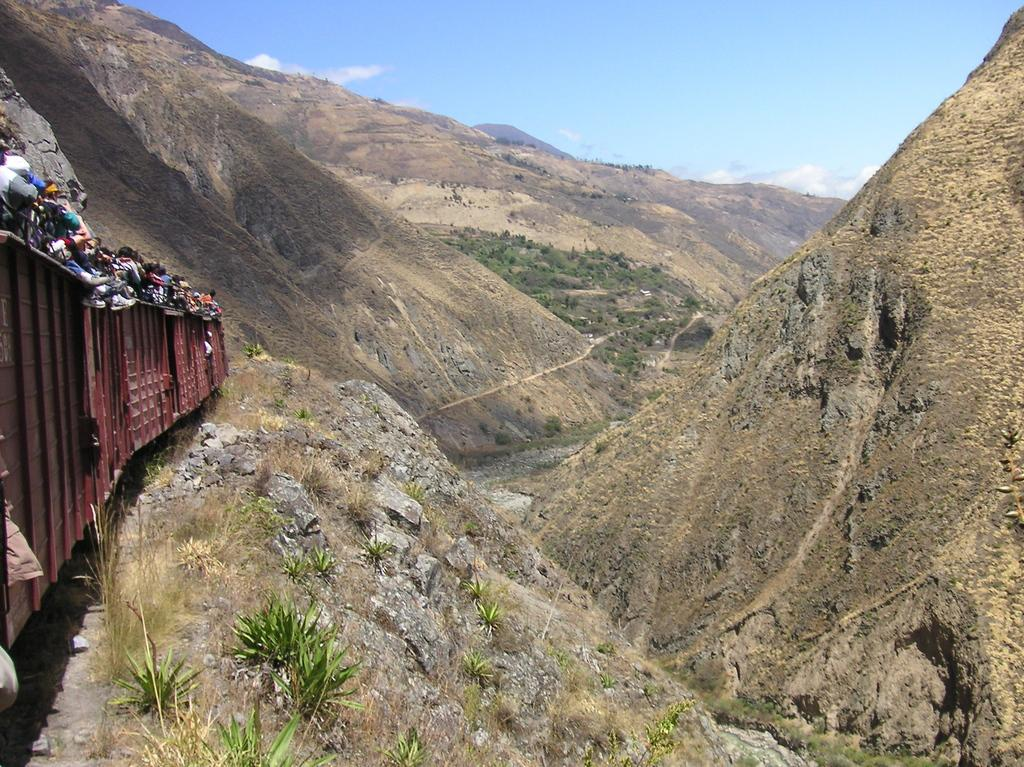What type of landscape can be seen in the image? There are hills in the image. What type of vegetation is present in the image? There is grass in the image. What mode of transportation is visible in the image? There is a train in the image. Are there any people associated with the train in the image? Yes, there are people standing in the train. What is visible in the background of the image? The sky is visible in the image. What is the chance of the train's brake failing in the image? There is no indication of the train's brake or any potential failure in the image. 